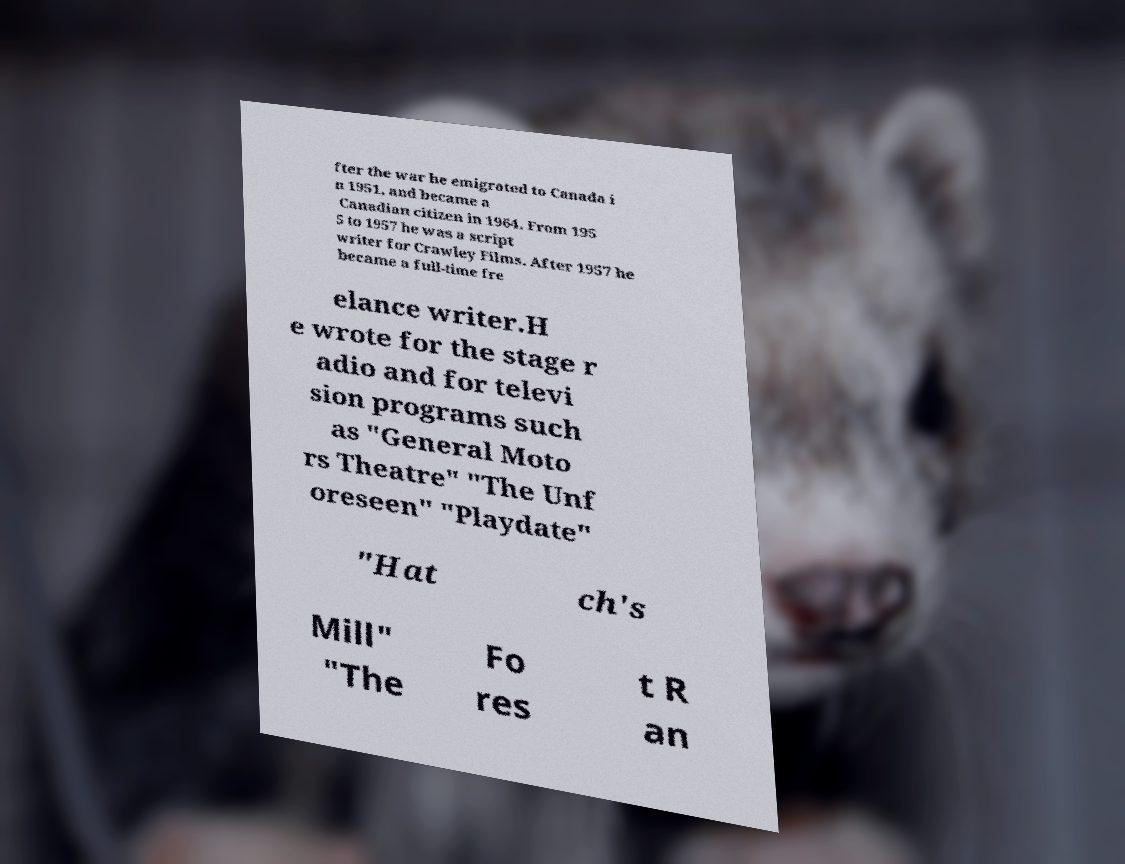What messages or text are displayed in this image? I need them in a readable, typed format. fter the war he emigrated to Canada i n 1951, and became a Canadian citizen in 1964. From 195 5 to 1957 he was a script writer for Crawley Films. After 1957 he became a full-time fre elance writer.H e wrote for the stage r adio and for televi sion programs such as "General Moto rs Theatre" "The Unf oreseen" "Playdate" "Hat ch's Mill" "The Fo res t R an 